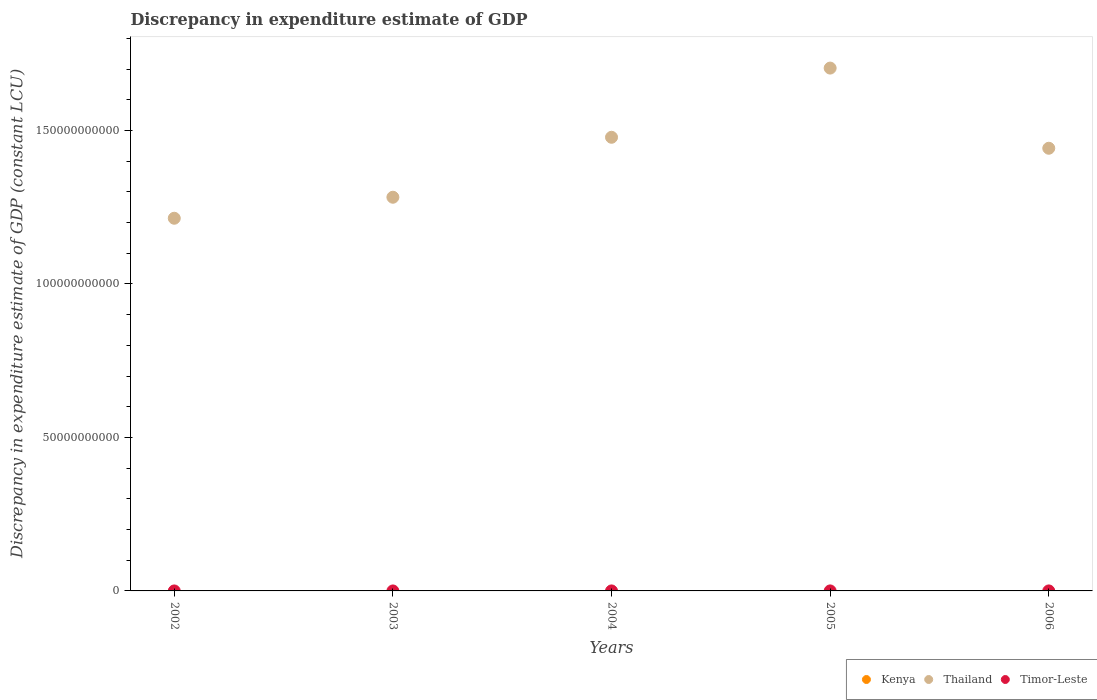How many different coloured dotlines are there?
Your response must be concise. 2. Across all years, what is the maximum discrepancy in expenditure estimate of GDP in Timor-Leste?
Offer a very short reply. 2.08e+06. Across all years, what is the minimum discrepancy in expenditure estimate of GDP in Thailand?
Make the answer very short. 1.21e+11. In which year was the discrepancy in expenditure estimate of GDP in Timor-Leste maximum?
Your response must be concise. 2005. What is the total discrepancy in expenditure estimate of GDP in Timor-Leste in the graph?
Offer a terse response. 2.17e+06. What is the difference between the discrepancy in expenditure estimate of GDP in Thailand in 2005 and that in 2006?
Keep it short and to the point. 2.61e+1. What is the difference between the discrepancy in expenditure estimate of GDP in Kenya in 2004 and the discrepancy in expenditure estimate of GDP in Timor-Leste in 2005?
Offer a very short reply. -2.08e+06. In the year 2004, what is the difference between the discrepancy in expenditure estimate of GDP in Timor-Leste and discrepancy in expenditure estimate of GDP in Thailand?
Offer a terse response. -1.48e+11. What is the ratio of the discrepancy in expenditure estimate of GDP in Thailand in 2003 to that in 2005?
Give a very brief answer. 0.75. Is the discrepancy in expenditure estimate of GDP in Thailand in 2002 less than that in 2005?
Keep it short and to the point. Yes. What is the difference between the highest and the second highest discrepancy in expenditure estimate of GDP in Thailand?
Offer a very short reply. 2.25e+1. What is the difference between the highest and the lowest discrepancy in expenditure estimate of GDP in Timor-Leste?
Your answer should be very brief. 2.08e+06. Is the sum of the discrepancy in expenditure estimate of GDP in Thailand in 2002 and 2006 greater than the maximum discrepancy in expenditure estimate of GDP in Kenya across all years?
Ensure brevity in your answer.  Yes. Is it the case that in every year, the sum of the discrepancy in expenditure estimate of GDP in Timor-Leste and discrepancy in expenditure estimate of GDP in Kenya  is greater than the discrepancy in expenditure estimate of GDP in Thailand?
Provide a succinct answer. No. Is the discrepancy in expenditure estimate of GDP in Kenya strictly greater than the discrepancy in expenditure estimate of GDP in Thailand over the years?
Give a very brief answer. No. Is the discrepancy in expenditure estimate of GDP in Kenya strictly less than the discrepancy in expenditure estimate of GDP in Timor-Leste over the years?
Your answer should be compact. Yes. How many dotlines are there?
Make the answer very short. 2. How many years are there in the graph?
Make the answer very short. 5. What is the difference between two consecutive major ticks on the Y-axis?
Provide a succinct answer. 5.00e+1. Are the values on the major ticks of Y-axis written in scientific E-notation?
Provide a short and direct response. No. Where does the legend appear in the graph?
Offer a very short reply. Bottom right. What is the title of the graph?
Offer a terse response. Discrepancy in expenditure estimate of GDP. Does "Nicaragua" appear as one of the legend labels in the graph?
Make the answer very short. No. What is the label or title of the X-axis?
Your answer should be very brief. Years. What is the label or title of the Y-axis?
Keep it short and to the point. Discrepancy in expenditure estimate of GDP (constant LCU). What is the Discrepancy in expenditure estimate of GDP (constant LCU) in Thailand in 2002?
Provide a succinct answer. 1.21e+11. What is the Discrepancy in expenditure estimate of GDP (constant LCU) in Timor-Leste in 2002?
Offer a terse response. 0. What is the Discrepancy in expenditure estimate of GDP (constant LCU) in Kenya in 2003?
Make the answer very short. 0. What is the Discrepancy in expenditure estimate of GDP (constant LCU) in Thailand in 2003?
Ensure brevity in your answer.  1.28e+11. What is the Discrepancy in expenditure estimate of GDP (constant LCU) of Timor-Leste in 2003?
Ensure brevity in your answer.  0. What is the Discrepancy in expenditure estimate of GDP (constant LCU) of Thailand in 2004?
Offer a terse response. 1.48e+11. What is the Discrepancy in expenditure estimate of GDP (constant LCU) in Timor-Leste in 2004?
Make the answer very short. 8.88e+04. What is the Discrepancy in expenditure estimate of GDP (constant LCU) of Thailand in 2005?
Your response must be concise. 1.70e+11. What is the Discrepancy in expenditure estimate of GDP (constant LCU) in Timor-Leste in 2005?
Provide a short and direct response. 2.08e+06. What is the Discrepancy in expenditure estimate of GDP (constant LCU) in Thailand in 2006?
Ensure brevity in your answer.  1.44e+11. What is the Discrepancy in expenditure estimate of GDP (constant LCU) of Timor-Leste in 2006?
Provide a short and direct response. 0. Across all years, what is the maximum Discrepancy in expenditure estimate of GDP (constant LCU) of Thailand?
Ensure brevity in your answer.  1.70e+11. Across all years, what is the maximum Discrepancy in expenditure estimate of GDP (constant LCU) in Timor-Leste?
Your response must be concise. 2.08e+06. Across all years, what is the minimum Discrepancy in expenditure estimate of GDP (constant LCU) in Thailand?
Offer a very short reply. 1.21e+11. Across all years, what is the minimum Discrepancy in expenditure estimate of GDP (constant LCU) in Timor-Leste?
Make the answer very short. 0. What is the total Discrepancy in expenditure estimate of GDP (constant LCU) in Thailand in the graph?
Ensure brevity in your answer.  7.12e+11. What is the total Discrepancy in expenditure estimate of GDP (constant LCU) in Timor-Leste in the graph?
Provide a succinct answer. 2.17e+06. What is the difference between the Discrepancy in expenditure estimate of GDP (constant LCU) in Thailand in 2002 and that in 2003?
Your response must be concise. -6.84e+09. What is the difference between the Discrepancy in expenditure estimate of GDP (constant LCU) in Thailand in 2002 and that in 2004?
Your answer should be compact. -2.64e+1. What is the difference between the Discrepancy in expenditure estimate of GDP (constant LCU) in Thailand in 2002 and that in 2005?
Provide a succinct answer. -4.89e+1. What is the difference between the Discrepancy in expenditure estimate of GDP (constant LCU) in Thailand in 2002 and that in 2006?
Offer a terse response. -2.28e+1. What is the difference between the Discrepancy in expenditure estimate of GDP (constant LCU) of Thailand in 2003 and that in 2004?
Offer a very short reply. -1.95e+1. What is the difference between the Discrepancy in expenditure estimate of GDP (constant LCU) in Thailand in 2003 and that in 2005?
Offer a very short reply. -4.21e+1. What is the difference between the Discrepancy in expenditure estimate of GDP (constant LCU) in Thailand in 2003 and that in 2006?
Your response must be concise. -1.60e+1. What is the difference between the Discrepancy in expenditure estimate of GDP (constant LCU) in Thailand in 2004 and that in 2005?
Provide a succinct answer. -2.25e+1. What is the difference between the Discrepancy in expenditure estimate of GDP (constant LCU) in Timor-Leste in 2004 and that in 2005?
Your answer should be compact. -1.99e+06. What is the difference between the Discrepancy in expenditure estimate of GDP (constant LCU) of Thailand in 2004 and that in 2006?
Keep it short and to the point. 3.58e+09. What is the difference between the Discrepancy in expenditure estimate of GDP (constant LCU) in Thailand in 2005 and that in 2006?
Your response must be concise. 2.61e+1. What is the difference between the Discrepancy in expenditure estimate of GDP (constant LCU) of Thailand in 2002 and the Discrepancy in expenditure estimate of GDP (constant LCU) of Timor-Leste in 2004?
Provide a short and direct response. 1.21e+11. What is the difference between the Discrepancy in expenditure estimate of GDP (constant LCU) of Thailand in 2002 and the Discrepancy in expenditure estimate of GDP (constant LCU) of Timor-Leste in 2005?
Your answer should be very brief. 1.21e+11. What is the difference between the Discrepancy in expenditure estimate of GDP (constant LCU) in Thailand in 2003 and the Discrepancy in expenditure estimate of GDP (constant LCU) in Timor-Leste in 2004?
Offer a terse response. 1.28e+11. What is the difference between the Discrepancy in expenditure estimate of GDP (constant LCU) in Thailand in 2003 and the Discrepancy in expenditure estimate of GDP (constant LCU) in Timor-Leste in 2005?
Your answer should be very brief. 1.28e+11. What is the difference between the Discrepancy in expenditure estimate of GDP (constant LCU) of Thailand in 2004 and the Discrepancy in expenditure estimate of GDP (constant LCU) of Timor-Leste in 2005?
Your response must be concise. 1.48e+11. What is the average Discrepancy in expenditure estimate of GDP (constant LCU) in Thailand per year?
Give a very brief answer. 1.42e+11. What is the average Discrepancy in expenditure estimate of GDP (constant LCU) in Timor-Leste per year?
Your response must be concise. 4.34e+05. In the year 2004, what is the difference between the Discrepancy in expenditure estimate of GDP (constant LCU) in Thailand and Discrepancy in expenditure estimate of GDP (constant LCU) in Timor-Leste?
Your answer should be very brief. 1.48e+11. In the year 2005, what is the difference between the Discrepancy in expenditure estimate of GDP (constant LCU) of Thailand and Discrepancy in expenditure estimate of GDP (constant LCU) of Timor-Leste?
Your answer should be compact. 1.70e+11. What is the ratio of the Discrepancy in expenditure estimate of GDP (constant LCU) in Thailand in 2002 to that in 2003?
Your answer should be compact. 0.95. What is the ratio of the Discrepancy in expenditure estimate of GDP (constant LCU) of Thailand in 2002 to that in 2004?
Keep it short and to the point. 0.82. What is the ratio of the Discrepancy in expenditure estimate of GDP (constant LCU) of Thailand in 2002 to that in 2005?
Provide a succinct answer. 0.71. What is the ratio of the Discrepancy in expenditure estimate of GDP (constant LCU) in Thailand in 2002 to that in 2006?
Keep it short and to the point. 0.84. What is the ratio of the Discrepancy in expenditure estimate of GDP (constant LCU) of Thailand in 2003 to that in 2004?
Make the answer very short. 0.87. What is the ratio of the Discrepancy in expenditure estimate of GDP (constant LCU) of Thailand in 2003 to that in 2005?
Provide a succinct answer. 0.75. What is the ratio of the Discrepancy in expenditure estimate of GDP (constant LCU) of Thailand in 2003 to that in 2006?
Your response must be concise. 0.89. What is the ratio of the Discrepancy in expenditure estimate of GDP (constant LCU) in Thailand in 2004 to that in 2005?
Offer a very short reply. 0.87. What is the ratio of the Discrepancy in expenditure estimate of GDP (constant LCU) in Timor-Leste in 2004 to that in 2005?
Ensure brevity in your answer.  0.04. What is the ratio of the Discrepancy in expenditure estimate of GDP (constant LCU) of Thailand in 2004 to that in 2006?
Your answer should be compact. 1.02. What is the ratio of the Discrepancy in expenditure estimate of GDP (constant LCU) in Thailand in 2005 to that in 2006?
Give a very brief answer. 1.18. What is the difference between the highest and the second highest Discrepancy in expenditure estimate of GDP (constant LCU) in Thailand?
Make the answer very short. 2.25e+1. What is the difference between the highest and the lowest Discrepancy in expenditure estimate of GDP (constant LCU) in Thailand?
Offer a very short reply. 4.89e+1. What is the difference between the highest and the lowest Discrepancy in expenditure estimate of GDP (constant LCU) in Timor-Leste?
Give a very brief answer. 2.08e+06. 